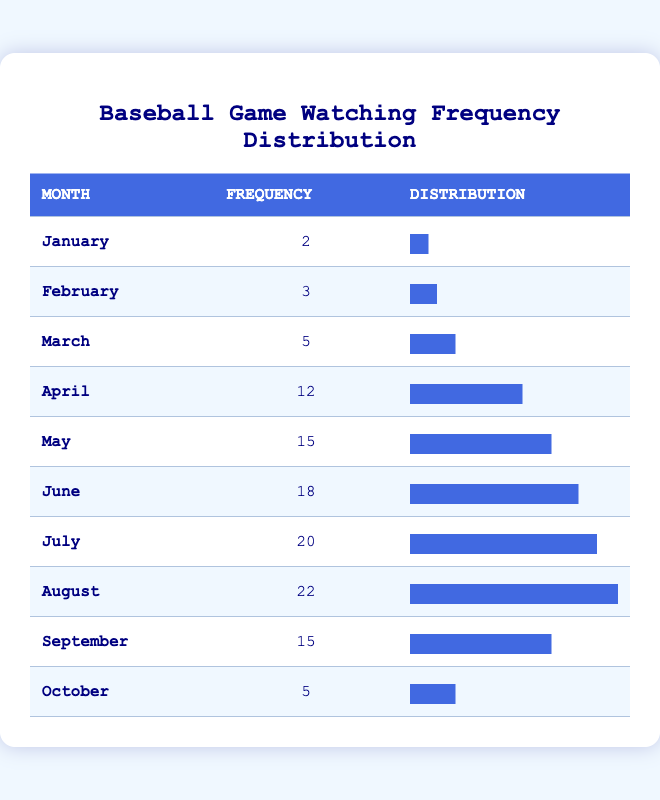What is the frequency of baseball games watched in August? The table shows that in August, the number of baseball games watched is 22.
Answer: 22 How many more baseball games were watched in July compared to January? In July, 20 games were watched and in January, 2 games were watched. The difference is 20 - 2 = 18.
Answer: 18 What is the total number of baseball games watched from April to June? The number of games watched in April is 12, in May is 15, and in June is 18. Adding these gives 12 + 15 + 18 = 45.
Answer: 45 Is the frequency of baseball games watched in September greater than in January? In September, 15 games were watched whereas in January, 2 games were watched. Since 15 is greater than 2, the statement is true.
Answer: Yes Which month had the highest frequency of baseball games watched and what was that frequency? The highest frequency can be found by looking through the data. August has the highest at 22 games watched.
Answer: August, 22 